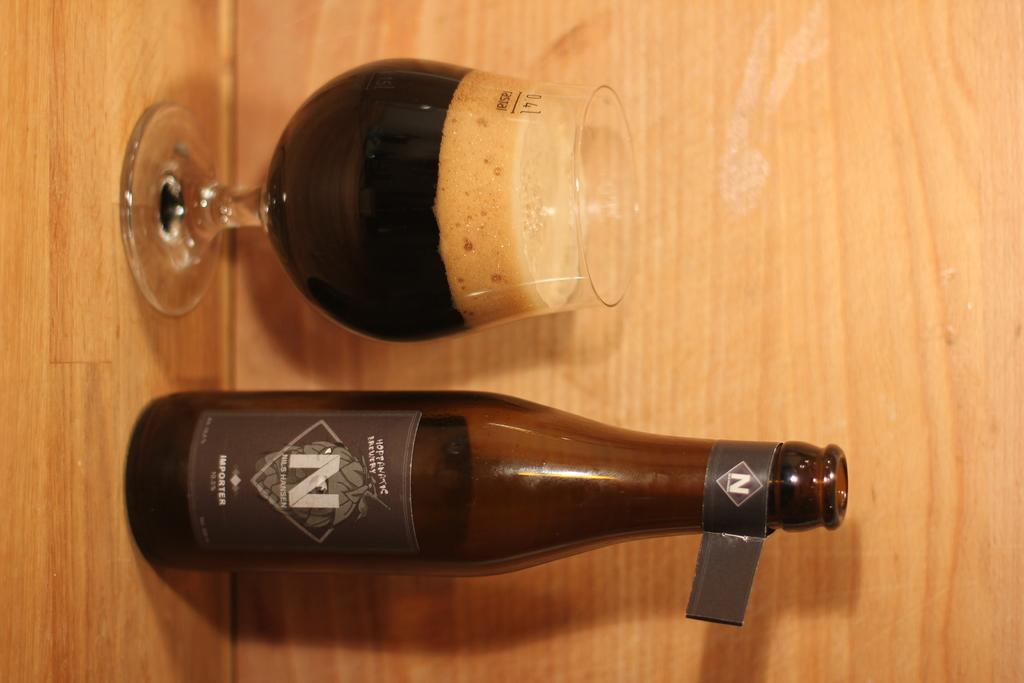<image>
Provide a brief description of the given image. A bottle of wine with the letter N on it next to a filled glass. 